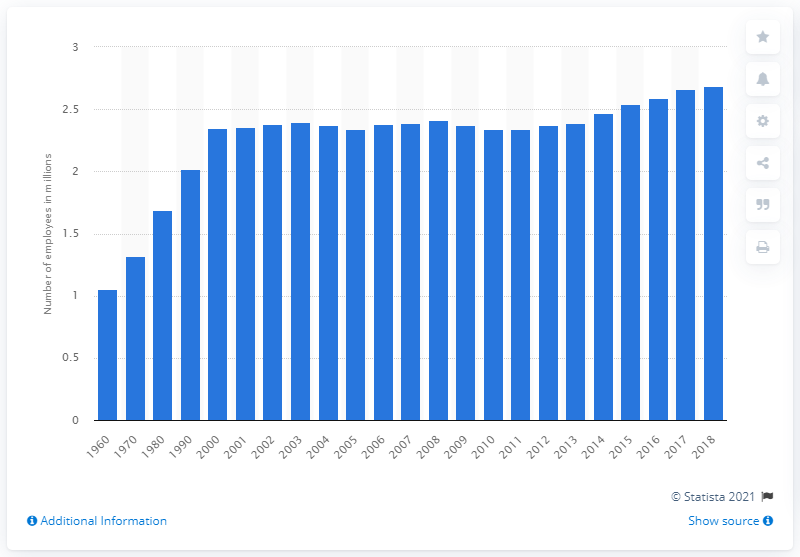Indicate a few pertinent items in this graphic. In 2018, there were approximately 2.69 million individuals employed in the insurance sector. 